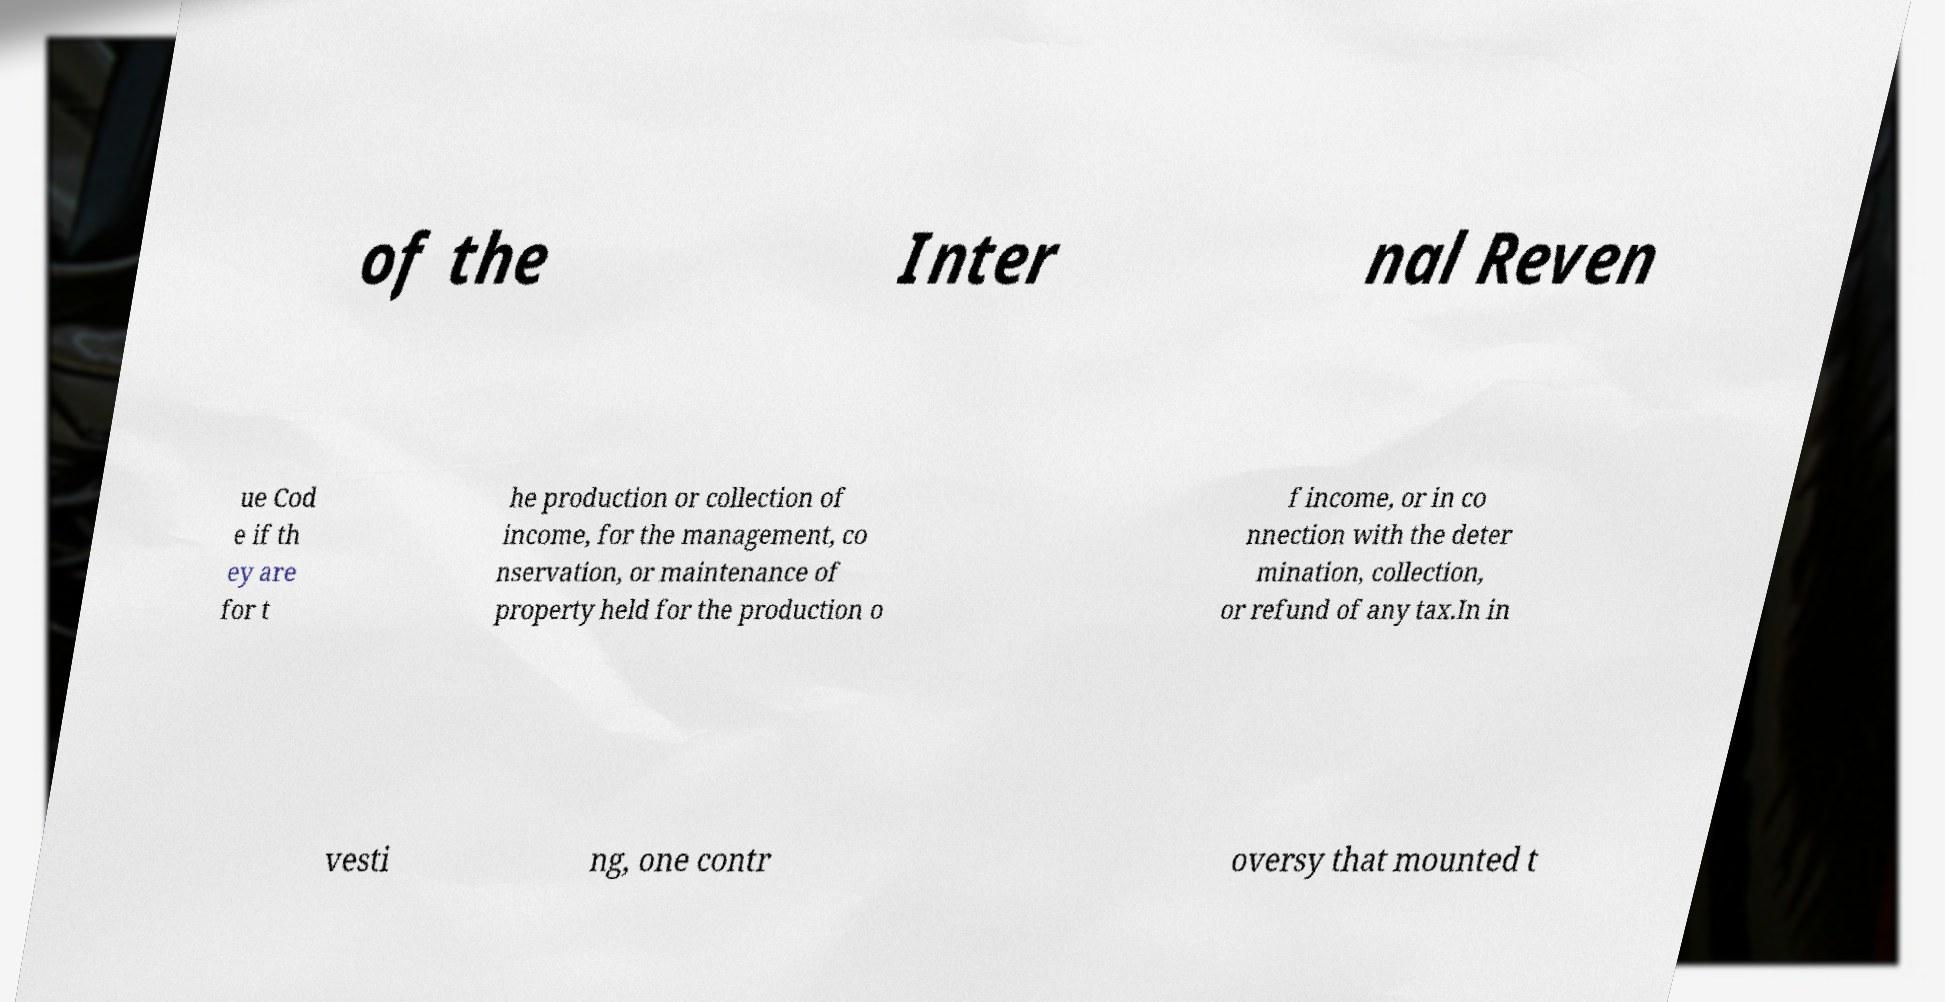Can you read and provide the text displayed in the image?This photo seems to have some interesting text. Can you extract and type it out for me? of the Inter nal Reven ue Cod e if th ey are for t he production or collection of income, for the management, co nservation, or maintenance of property held for the production o f income, or in co nnection with the deter mination, collection, or refund of any tax.In in vesti ng, one contr oversy that mounted t 